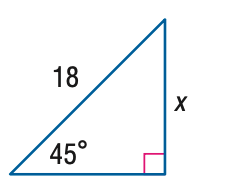Question: Find x.
Choices:
A. 9 \sqrt { 2 }
B. 9 \sqrt { 3 }
C. 18 \sqrt { 2 }
D. 18 \sqrt { 3 }
Answer with the letter. Answer: A 